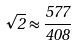Convert formula to latex. <formula><loc_0><loc_0><loc_500><loc_500>\sqrt { 2 } \approx \frac { 5 7 7 } { 4 0 8 }</formula> 